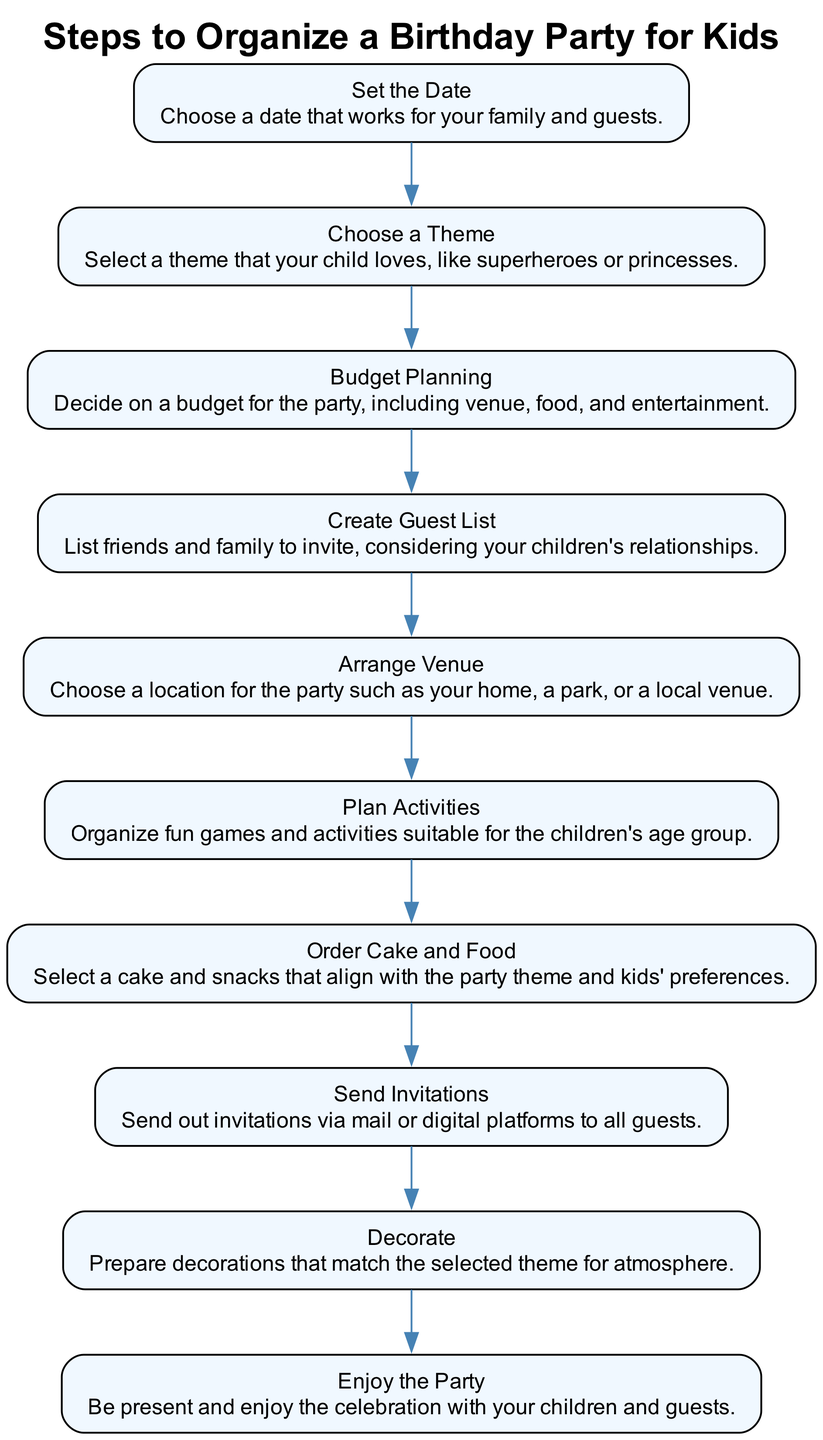What's the first step in organizing a birthday party? The first step in the flow chart is labeled "Set the Date." It indicates that choosing a date is the initial action required for organizing the party.
Answer: Set the Date How many total steps are there in the diagram? The flow chart contains a total of ten steps, as it lists ten distinct actions that need to be taken for planning the birthday party.
Answer: 10 What should you do after choosing a theme? According to the flow chart, after "Choose a Theme," the next step is "Budget Planning," meaning it's essential to decide on a budget right after selecting the party theme.
Answer: Budget Planning Which step comes before sending invitations? The flow chart clearly shows that "Decorate" immediately precedes "Send Invitations," indicating that decoration should be completed prior to inviting guests.
Answer: Decorate Which step requires considering your children's relationships? In the diagram, the step "Create Guest List" specifically mentions that one should consider the children's relationships when listing friends and family to invite for the party.
Answer: Create Guest List What is the last step in the flow chart? The final action in the diagram is "Enjoy the Party," which highlights that being present and enjoying the celebration is the ultimate goal of all prior planning.
Answer: Enjoy the Party How does the flow chart depict the relationship between arranging the venue and planning activities? The flow chart shows that after "Arrange Venue," the subsequent step is "Plan Activities," indicating that once a venue is secured, the next step is to organize activities for the event.
Answer: Plan Activities What step involves selecting food and snacks? The step labeled "Order Cake and Food" explains that this action includes selecting items that align with the party theme and the children's preferences, making it the specific action for food selection.
Answer: Order Cake and Food What is the purpose of the "Budget Planning" step? The "Budget Planning" step is set to ensure that you decide on a financial plan for the party, covering expenses like venue, food, and entertainment, which is crucial for organizing within financial means.
Answer: Decide on a budget 